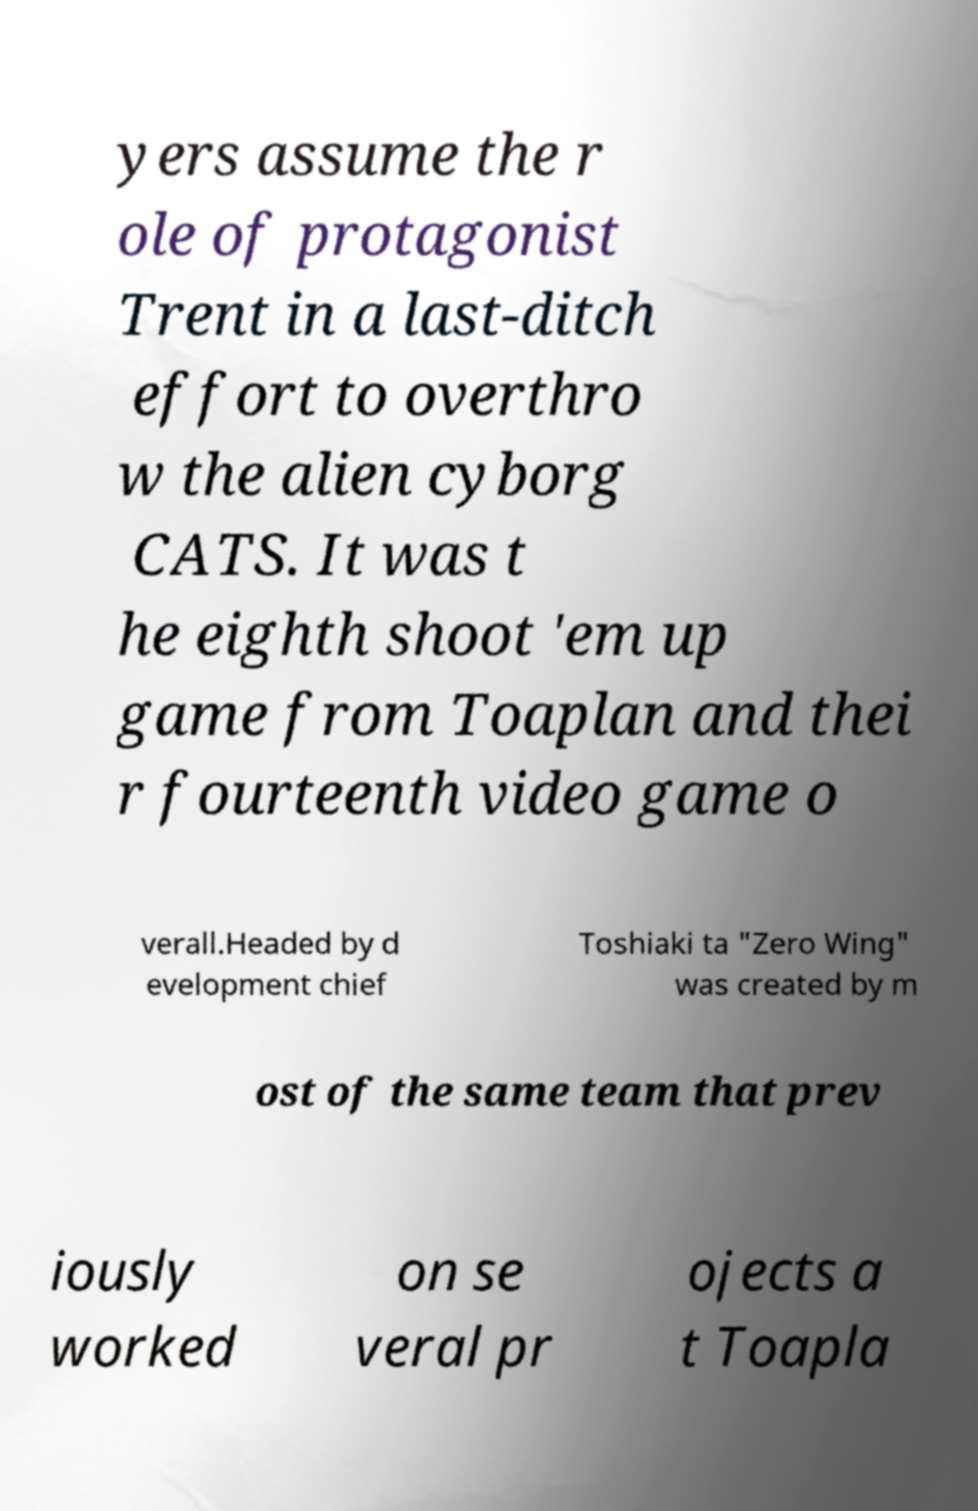Can you accurately transcribe the text from the provided image for me? yers assume the r ole of protagonist Trent in a last-ditch effort to overthro w the alien cyborg CATS. It was t he eighth shoot 'em up game from Toaplan and thei r fourteenth video game o verall.Headed by d evelopment chief Toshiaki ta "Zero Wing" was created by m ost of the same team that prev iously worked on se veral pr ojects a t Toapla 